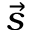Convert formula to latex. <formula><loc_0><loc_0><loc_500><loc_500>\vec { s }</formula> 